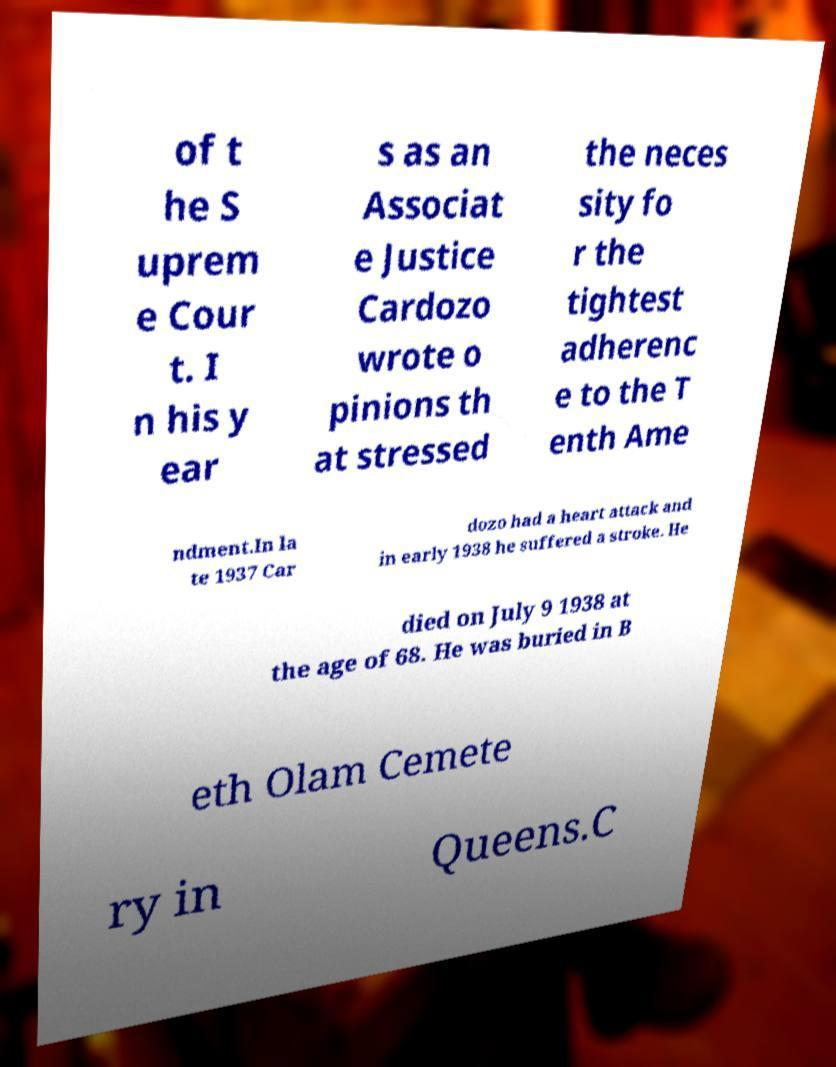Could you assist in decoding the text presented in this image and type it out clearly? of t he S uprem e Cour t. I n his y ear s as an Associat e Justice Cardozo wrote o pinions th at stressed the neces sity fo r the tightest adherenc e to the T enth Ame ndment.In la te 1937 Car dozo had a heart attack and in early 1938 he suffered a stroke. He died on July 9 1938 at the age of 68. He was buried in B eth Olam Cemete ry in Queens.C 